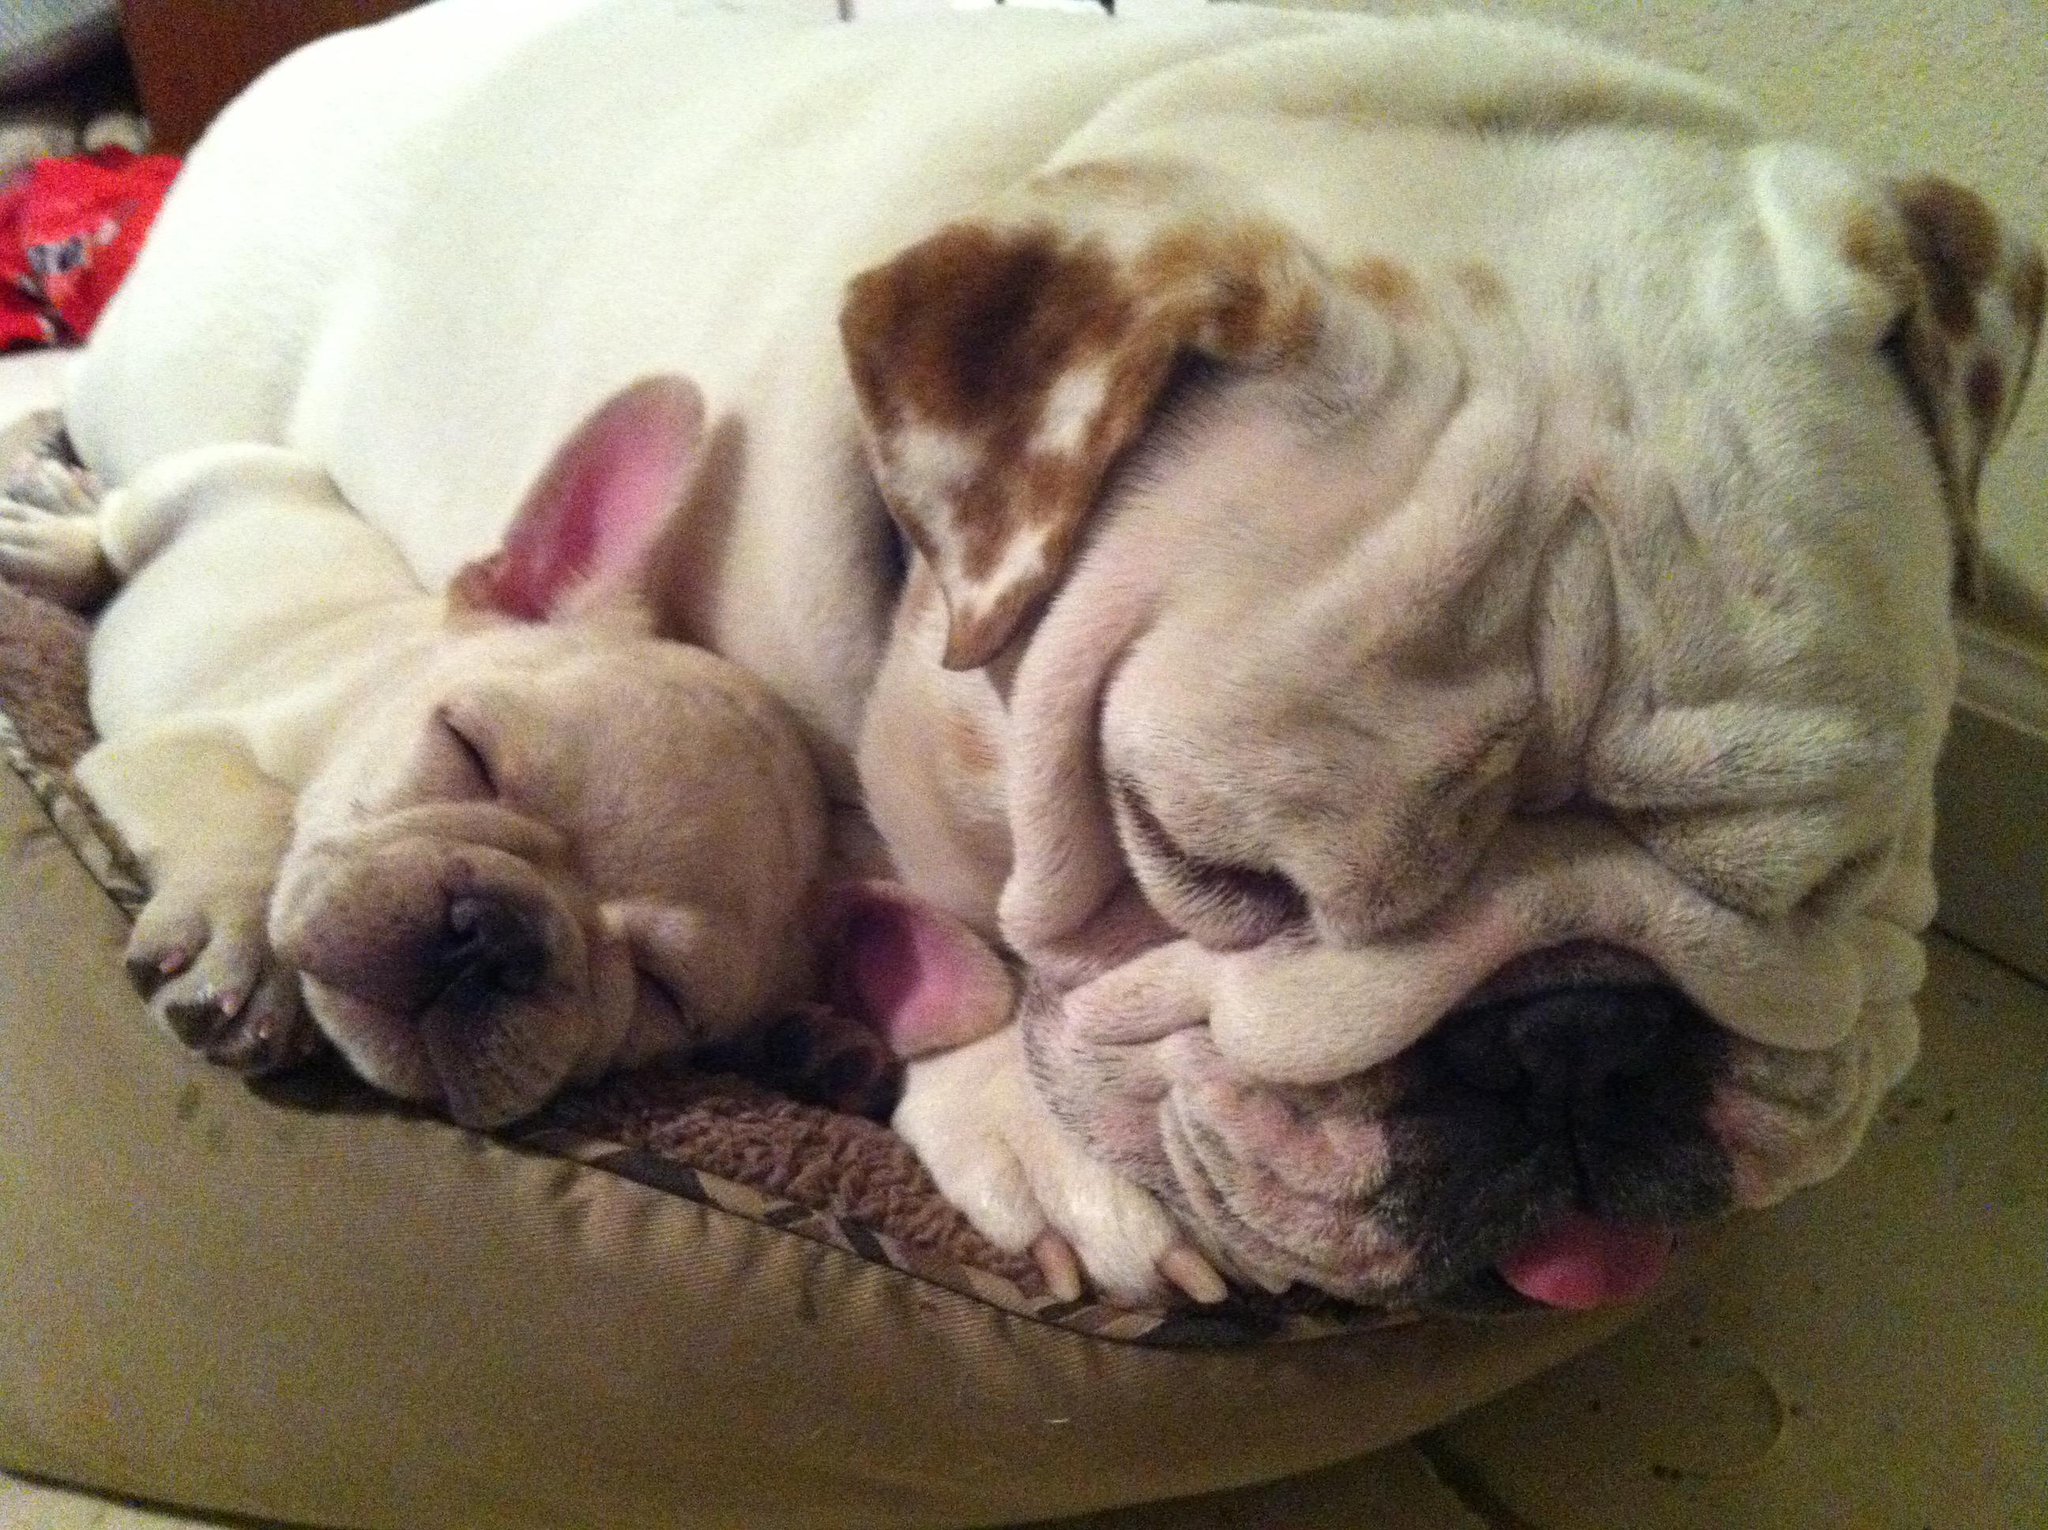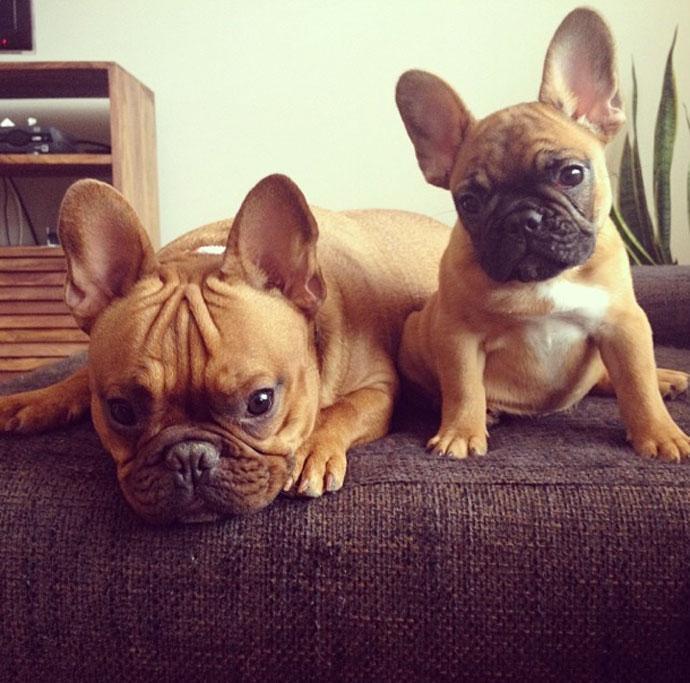The first image is the image on the left, the second image is the image on the right. Assess this claim about the two images: "An image contains one black puppy with its front paws around one white puppy.". Correct or not? Answer yes or no. No. The first image is the image on the left, the second image is the image on the right. Examine the images to the left and right. Is the description "There is at least one black french bulldog that is hugging a white dog." accurate? Answer yes or no. No. 